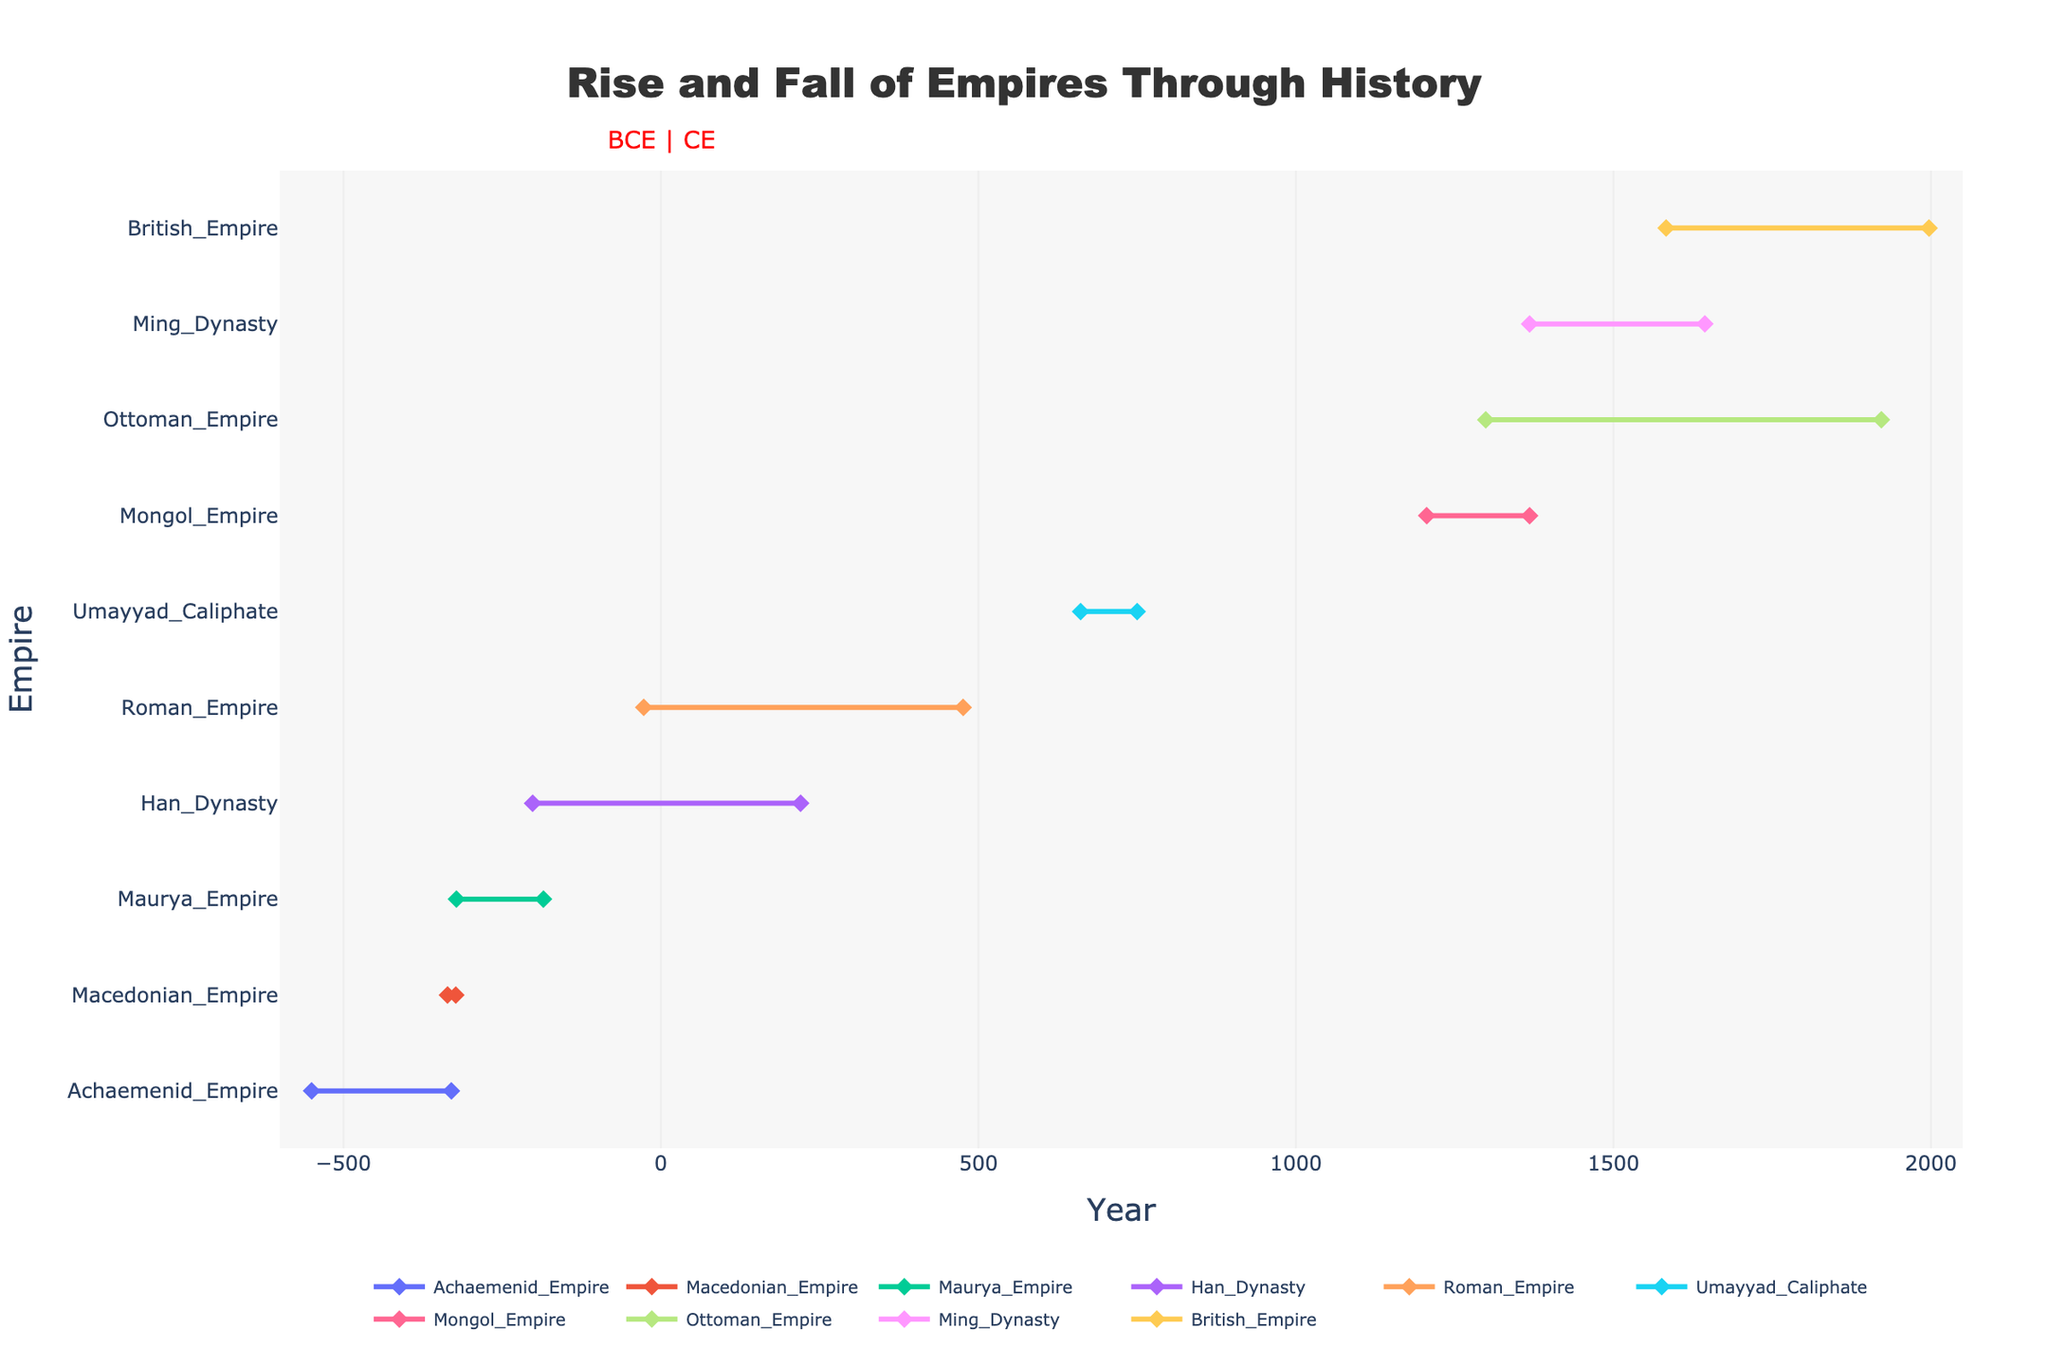What's the title of the plot? The title of the plot is displayed prominently at the top of the figure in large, bold fonts. The title reads "Rise and Fall of Empires Through History."
Answer: Rise and Fall of Empires Through History What is the range of years displayed on the x-axis? The x-axis represents the years and is shown with ticks. The range covers from -600 to 2050, as can be seen by the first and last ticks on the x-axis.
Answer: -600 to 2050 Which empire had the longest duration? To find the longest duration, calculate the difference between the End_Year and Start_Year for each empire and then identify the largest. The Ottoman Empire lasted the longest, from 1299 to 1922, which is 623 years.
Answer: Ottoman Empire What was the shortest-lasting empire? The shortest-lasting empire can be identified by finding the smallest difference between End_Year and Start_Year. The Macedonian Empire lasted from -336 to -323, which is 13 years.
Answer: Macedonian Empire How many empires existed before the Common Era (BCE)? Empires that existed before the Common Era will have their Start_Year and/or End_Year as negative values. These are the Achaemenid Empire, Macedonian Empire, Maurya Empire, Roman Empire, and Han Dynasty.
Answer: 5 Which empire ended closest to the year 2000 CE? Look at the End_Year column and identify the one closest to 2000 CE. The British Empire ended in 1997, which is the closest to 2000.
Answer: British Empire Which empire started first in CE (Common Era)? The first empire starting in the Common Era can be identified by finding the smallest positive Start_Year. The Umayyad Caliphate started in 661 CE.
Answer: Umayyad Caliphate Was there any overlap between the Han Dynasty and the Roman Empire? To determine the overlap, compare the time ranges of the Han Dynasty (-202 to 220) and the Roman Empire (-27 to 476). They overlapped from -27 to 220.
Answer: Yes What is the average duration of all empires listed? Calculate the duration of each empire and then find the average:
((220 + 13 + 137 + 503 + 422 + 89 + 162 + 623 + 276 + 414) / 10 = 285.9)
Answer: 285.9 years Between the Mongol Empire and the Ottoman Empire, which lasted longer? Compare the durations:
Mongol Empire (1206 to 1368) lasted 162 years.
Ottoman Empire (1299 to 1922) lasted 623 years.
Answer: Ottoman Empire 